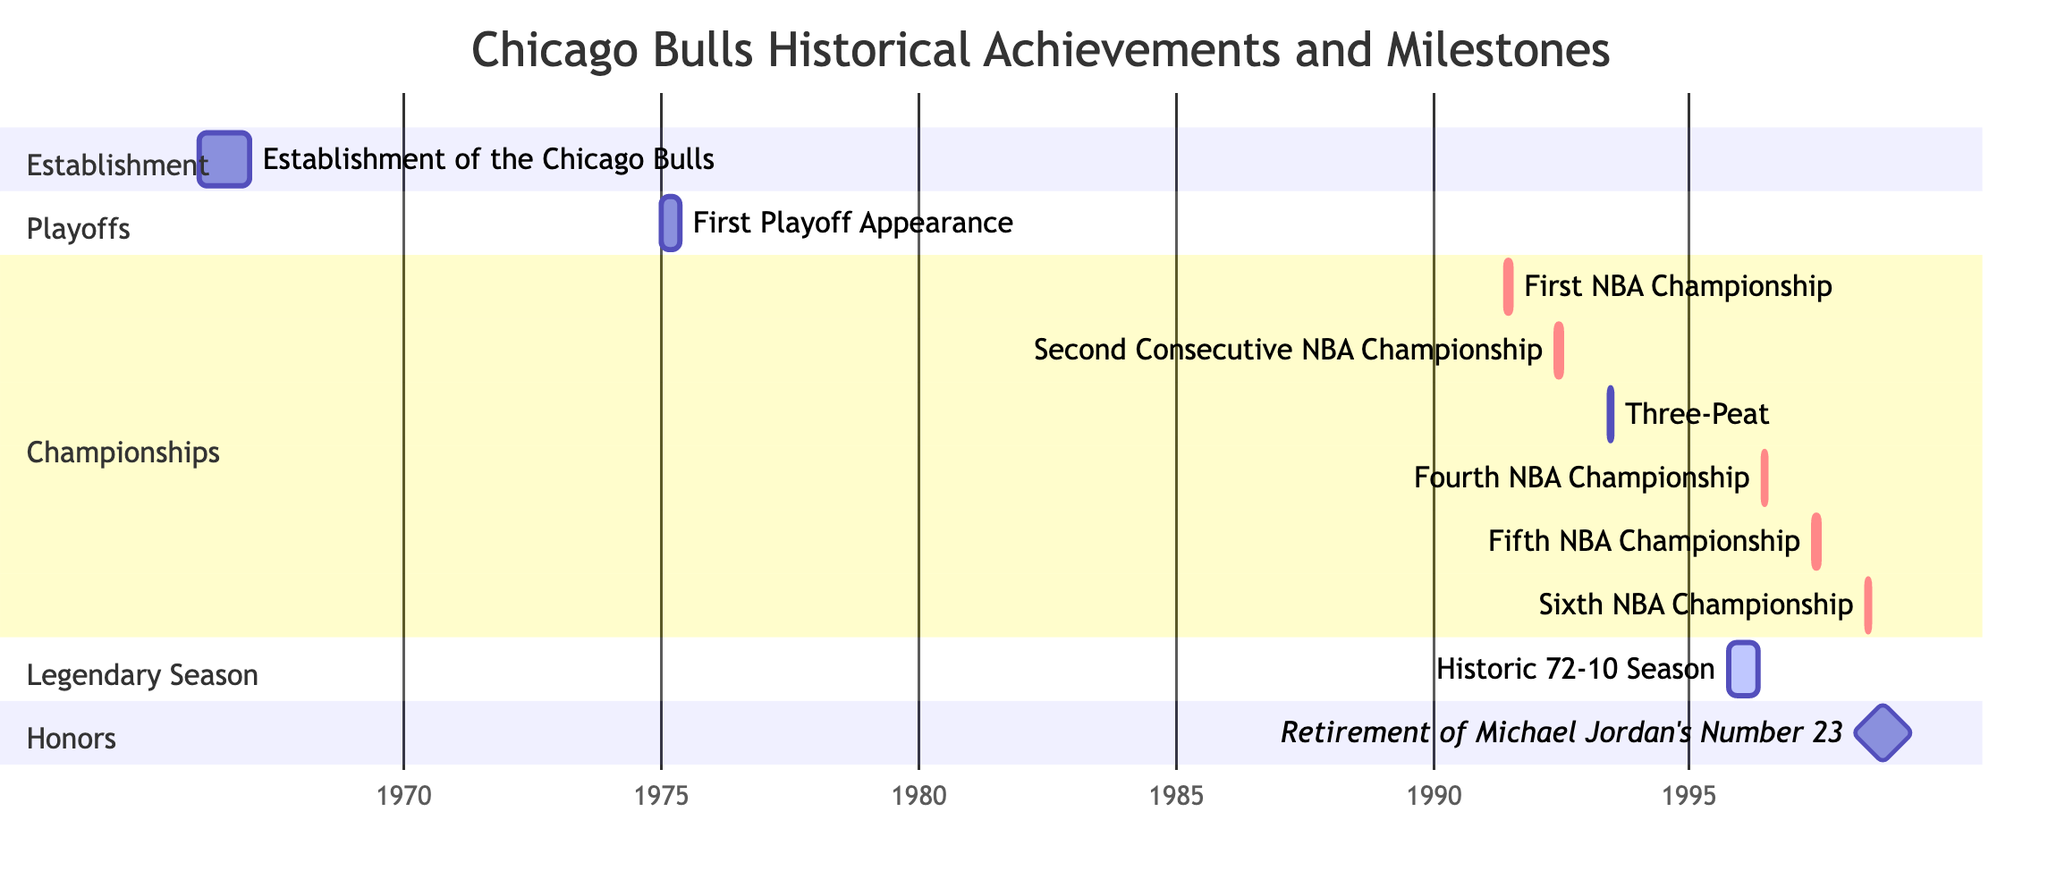What year was the Chicago Bulls established? The task labeled "Establishment of the Chicago Bulls" indicates a start date of January 1, 1966. Therefore, the establishment occurred in the year 1966.
Answer: 1966 How many NBA Championships did the Chicago Bulls win? The Championships section lists a total of six NBA Championships from 1991 to 1998. Counting each of those milestones results in six championships.
Answer: 6 Which event immediately followed the "Historic 72-10 Season"? Looking at the Gantt chart, after the "Historic 72-10 Season" that ended on April 30, 1996, the next event is the Fourth NBA Championship starting June 1, 1996.
Answer: Fourth NBA Championship What is the duration of the Historic 72-10 Season? The "Historic 72-10 Season" runs from October 1, 1995, to April 30, 1996. Calculating the days from October 1, 1995, to April 30, 1996, gives a total of 212 days.
Answer: 212 days In what year did Michael Jordan's number 23 get retired? The diagram lists the "Retirement of Michael Jordan's Number 23" starting on October 1, 1998, with no duration indicated, suggesting it is a significant milestone event that takes place in the year 1998.
Answer: 1998 What task has the longest duration in the chart? The "Historic 72-10 Season" has the longest duration of 212 days as it spans from October 1, 1995, to April 30, 1996, clearly visible in the timeline when compared to other events.
Answer: Historic 72-10 Season How many championships did the Bulls win consecutively from 1991 to 1993? The Gantt chart indicates that the Bulls won three consecutive championships from June 1991 to June 1993, as each task spans a month and follows sequentially.
Answer: 3 Which event is marked as a milestone? The "Retirement of Michael Jordan's Number 23" is marked with the label "milestone" in the Gantt chart, denoting its significance.
Answer: Retirement of Michael Jordan's Number 23 